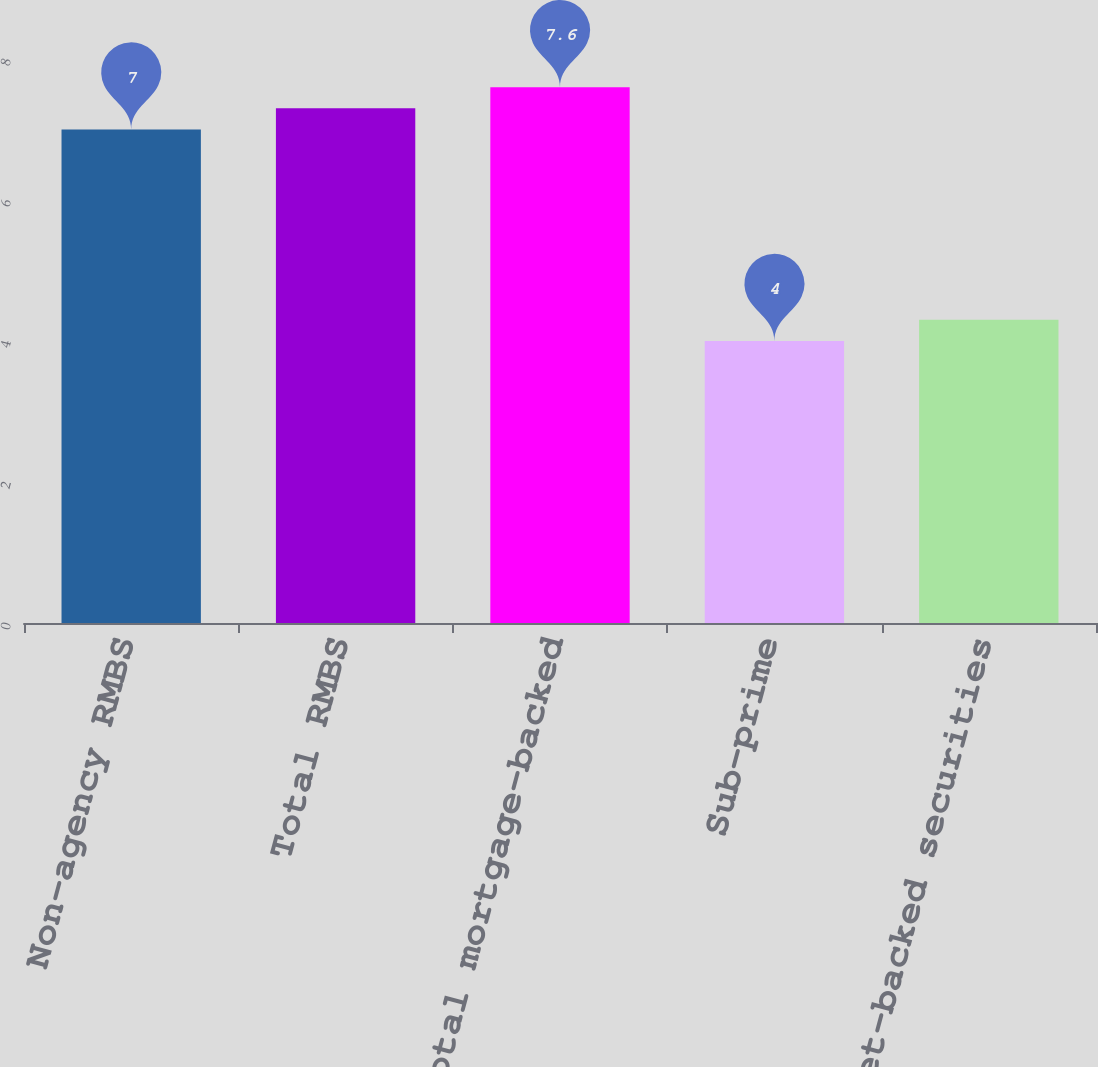Convert chart. <chart><loc_0><loc_0><loc_500><loc_500><bar_chart><fcel>Non-agency RMBS<fcel>Total RMBS<fcel>Total mortgage-backed<fcel>Sub-prime<fcel>Total asset-backed securities<nl><fcel>7<fcel>7.3<fcel>7.6<fcel>4<fcel>4.3<nl></chart> 